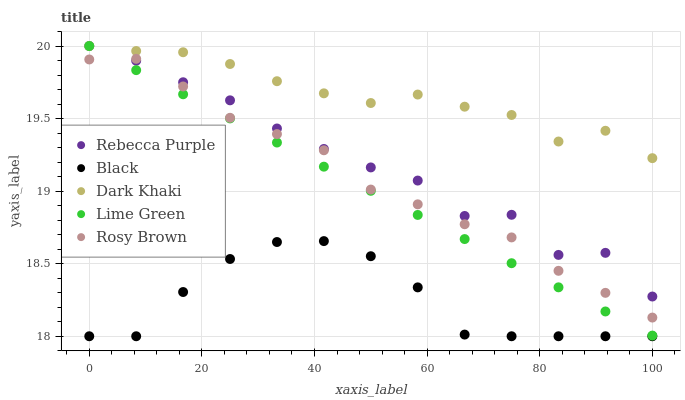Does Black have the minimum area under the curve?
Answer yes or no. Yes. Does Dark Khaki have the maximum area under the curve?
Answer yes or no. Yes. Does Lime Green have the minimum area under the curve?
Answer yes or no. No. Does Lime Green have the maximum area under the curve?
Answer yes or no. No. Is Lime Green the smoothest?
Answer yes or no. Yes. Is Rebecca Purple the roughest?
Answer yes or no. Yes. Is Rosy Brown the smoothest?
Answer yes or no. No. Is Rosy Brown the roughest?
Answer yes or no. No. Does Black have the lowest value?
Answer yes or no. Yes. Does Lime Green have the lowest value?
Answer yes or no. No. Does Rebecca Purple have the highest value?
Answer yes or no. Yes. Does Rosy Brown have the highest value?
Answer yes or no. No. Is Rosy Brown less than Dark Khaki?
Answer yes or no. Yes. Is Dark Khaki greater than Black?
Answer yes or no. Yes. Does Rosy Brown intersect Lime Green?
Answer yes or no. Yes. Is Rosy Brown less than Lime Green?
Answer yes or no. No. Is Rosy Brown greater than Lime Green?
Answer yes or no. No. Does Rosy Brown intersect Dark Khaki?
Answer yes or no. No. 